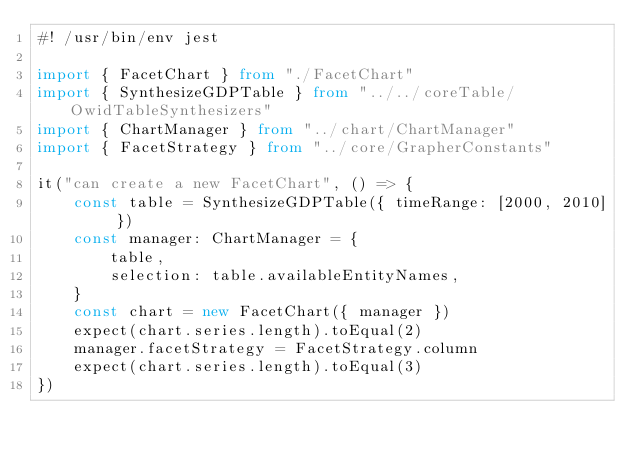<code> <loc_0><loc_0><loc_500><loc_500><_TypeScript_>#! /usr/bin/env jest

import { FacetChart } from "./FacetChart"
import { SynthesizeGDPTable } from "../../coreTable/OwidTableSynthesizers"
import { ChartManager } from "../chart/ChartManager"
import { FacetStrategy } from "../core/GrapherConstants"

it("can create a new FacetChart", () => {
    const table = SynthesizeGDPTable({ timeRange: [2000, 2010] })
    const manager: ChartManager = {
        table,
        selection: table.availableEntityNames,
    }
    const chart = new FacetChart({ manager })
    expect(chart.series.length).toEqual(2)
    manager.facetStrategy = FacetStrategy.column
    expect(chart.series.length).toEqual(3)
})
</code> 